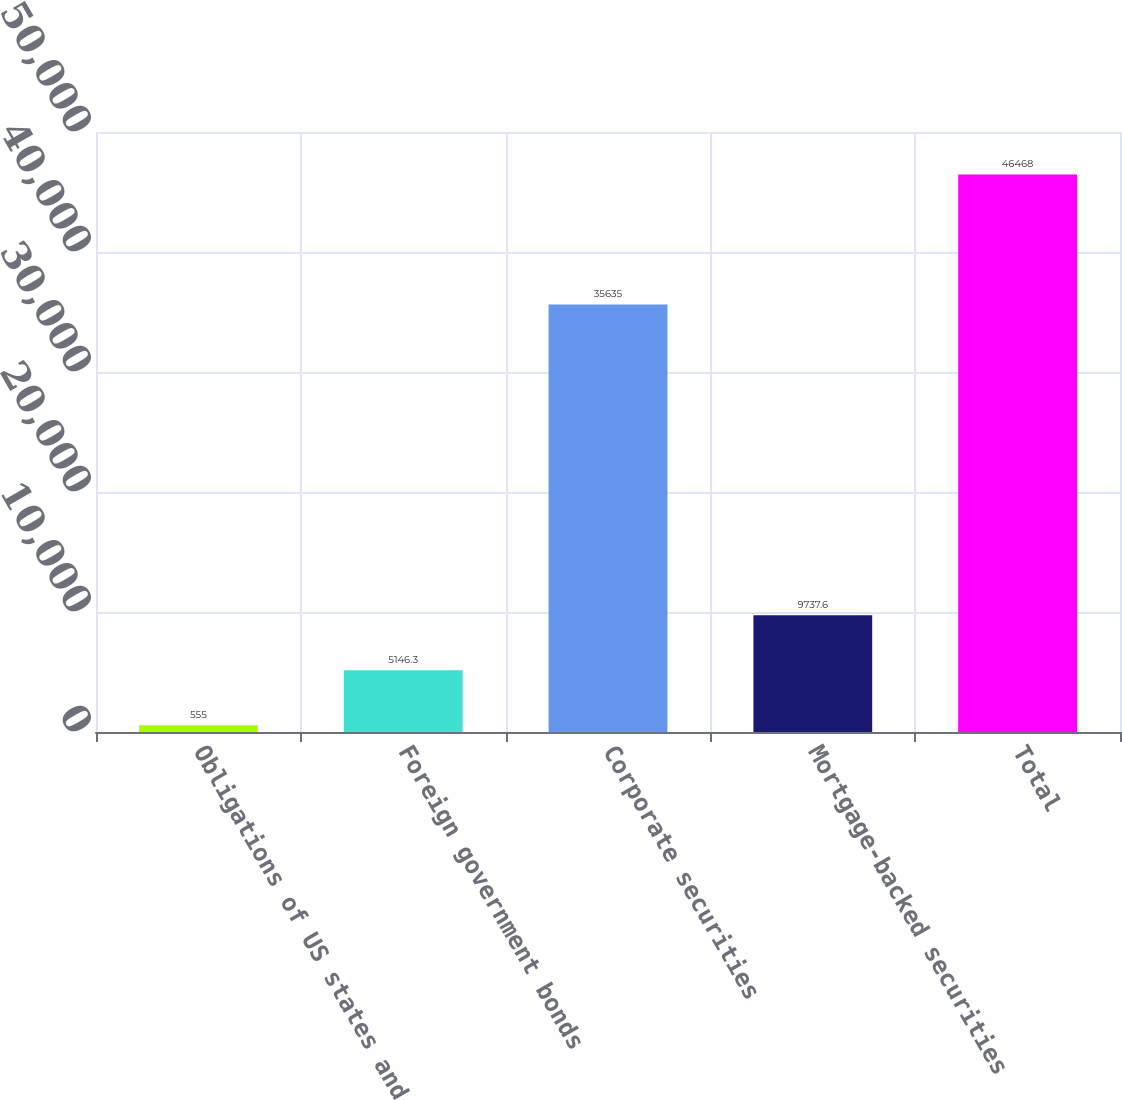Convert chart. <chart><loc_0><loc_0><loc_500><loc_500><bar_chart><fcel>Obligations of US states and<fcel>Foreign government bonds<fcel>Corporate securities<fcel>Mortgage-backed securities<fcel>Total<nl><fcel>555<fcel>5146.3<fcel>35635<fcel>9737.6<fcel>46468<nl></chart> 